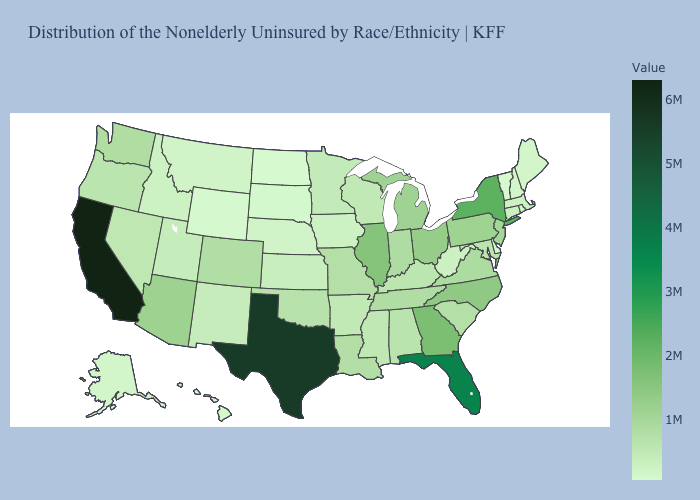Does South Carolina have a lower value than Hawaii?
Give a very brief answer. No. Does Delaware have the lowest value in the South?
Keep it brief. Yes. Does Indiana have a higher value than California?
Quick response, please. No. Is the legend a continuous bar?
Concise answer only. Yes. 